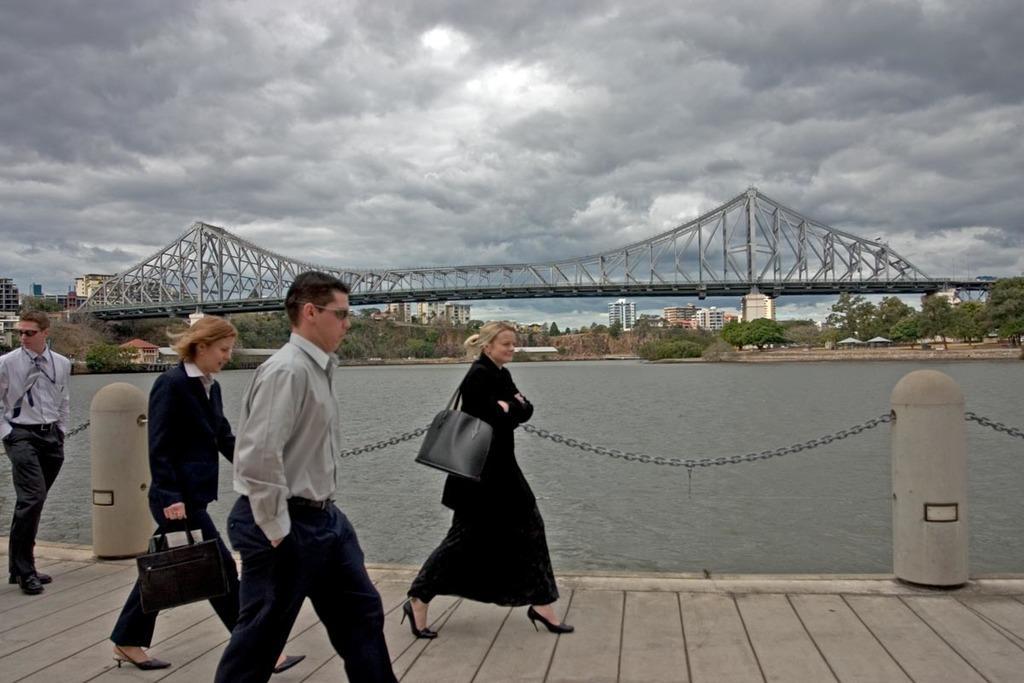Could you give a brief overview of what you see in this image? In this image there is a path on that path two women and two men are walking, behind the path there is a river, across the river there is a bridge, in the background there are trees, buildings and a cloudy sky. 